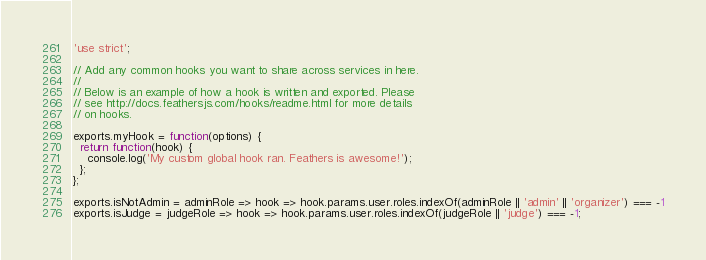<code> <loc_0><loc_0><loc_500><loc_500><_JavaScript_>'use strict';

// Add any common hooks you want to share across services in here.
// 
// Below is an example of how a hook is written and exported. Please
// see http://docs.feathersjs.com/hooks/readme.html for more details
// on hooks.

exports.myHook = function(options) {
  return function(hook) {
    console.log('My custom global hook ran. Feathers is awesome!');
  };
};

exports.isNotAdmin = adminRole => hook => hook.params.user.roles.indexOf(adminRole || 'admin' || 'organizer') === -1
exports.isJudge = judgeRole => hook => hook.params.user.roles.indexOf(judgeRole || 'judge') === -1;
</code> 